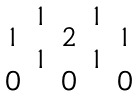Convert formula to latex. <formula><loc_0><loc_0><loc_500><loc_500>\begin{smallmatrix} & 1 & & 1 \\ 1 & & 2 & & 1 \\ & 1 & & 1 \\ 0 & & 0 & & 0 \end{smallmatrix}</formula> 